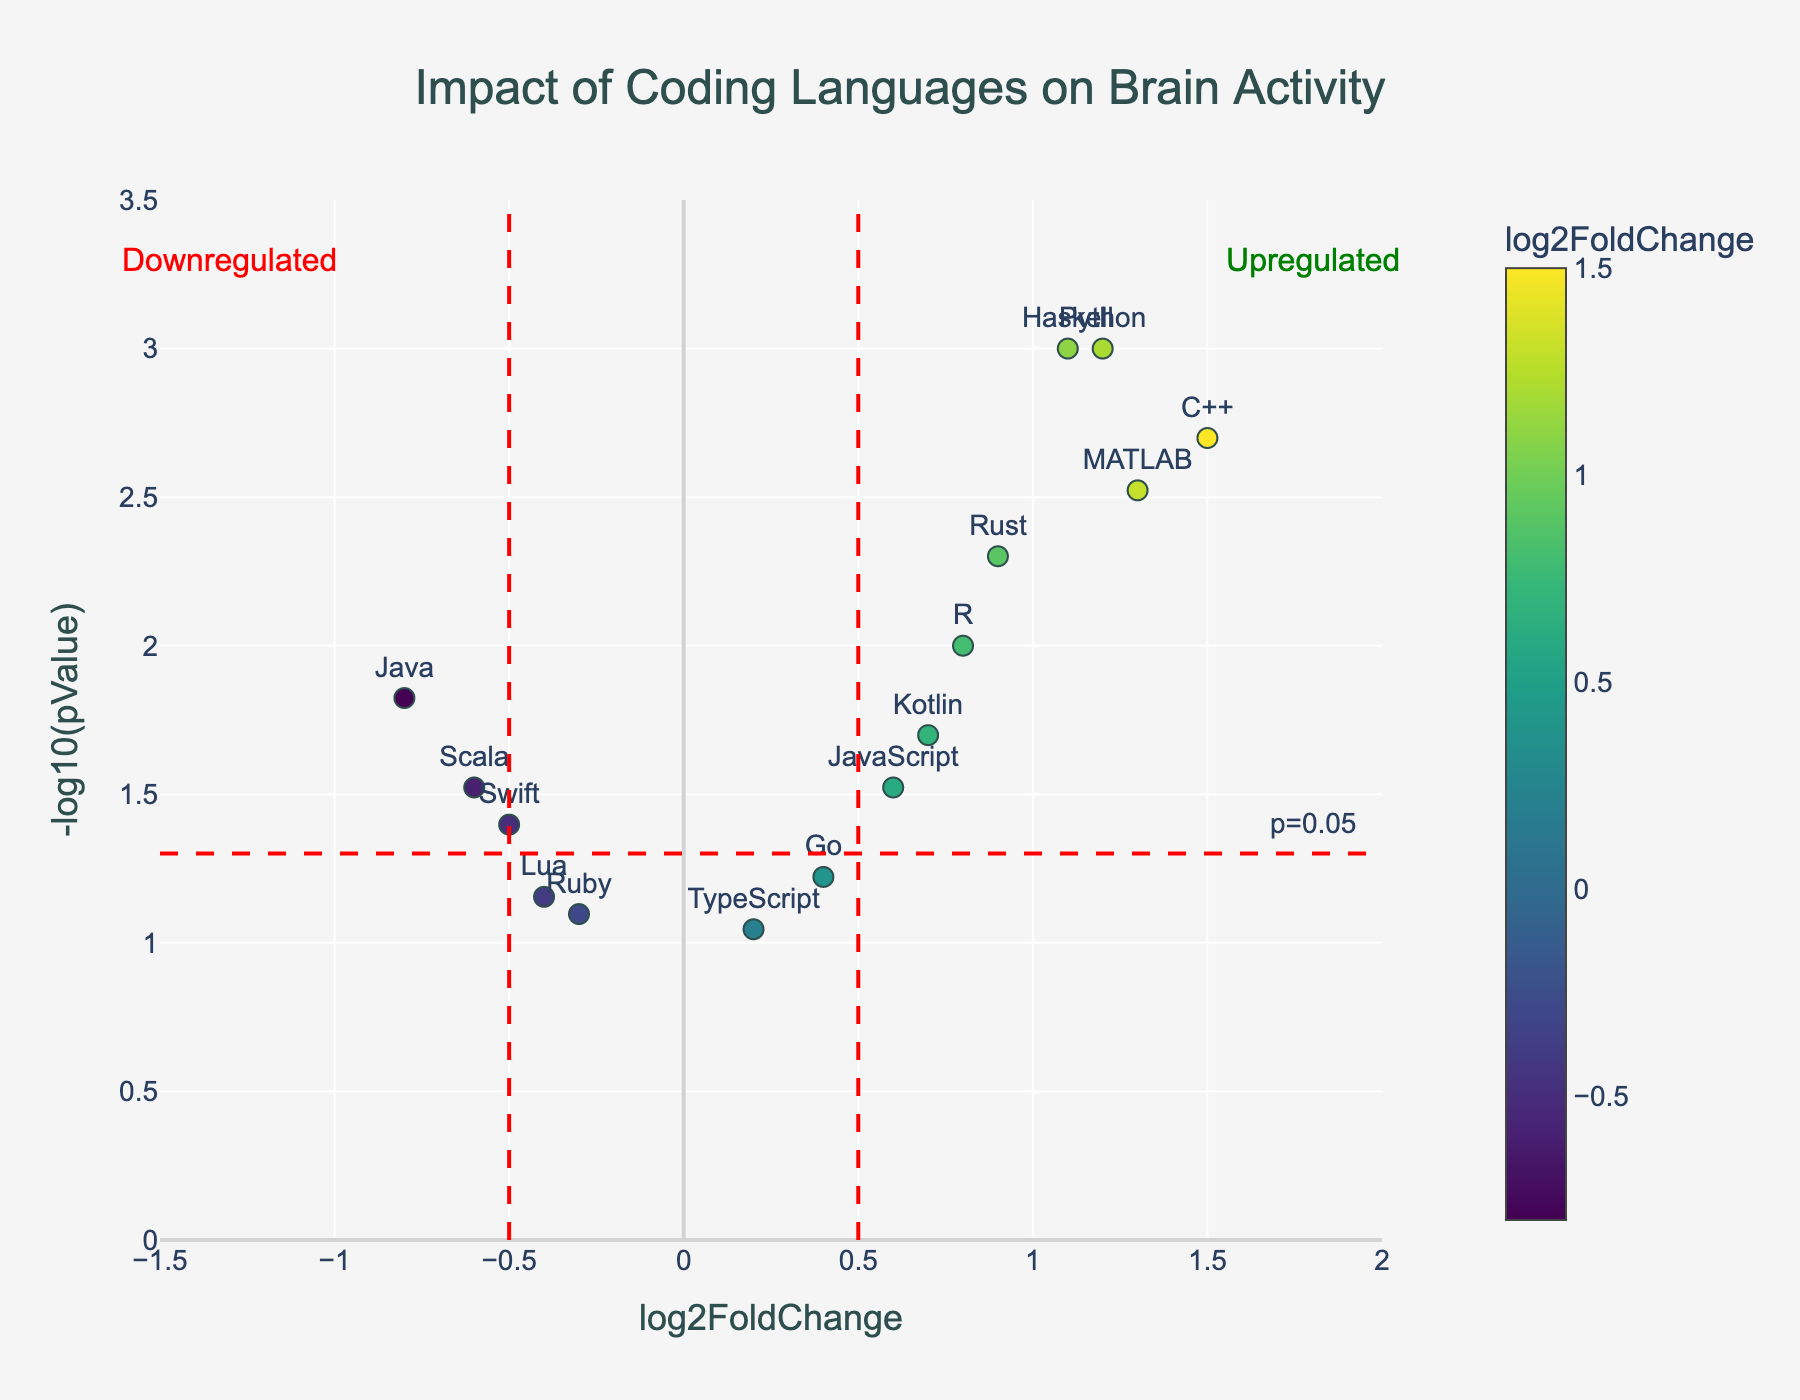Which coding language has the highest log2FoldChange? Look for the data point on the horizontal axis with the maximum log2FoldChange value. Python has a log2FoldChange of 1.2, JavaScript has 0.6, C++ has 1.5, and so on.
Answer: C++ Which coding language has the lowest p-value? Check the vertical axis for the data point with the largest -log10(pValue) value. Python has a -log10(pValue) of 3, C++ has 2.7, Rust has 2.3, and so on.
Answer: Python How many coding languages have a p-value below 0.05? Identify the data points above the horizontal line representing p=0.05 (-log10(0.05) ≈ 1.3). Count the points above this line.
Answer: 9 Which coding languages are considered upregulated based on the plot? Look for data points to the right of the vertical line at log2FoldChange=0.5. Upregulated languages have log2FoldChange greater than 0.5.
Answer: Python, JavaScript, C++, Kotlin, Haskell, Rust, MATLAB, R What is the log2FoldChange for the language Ruby? Identify the data point labeled Ruby and check its position on the horizontal axis.
Answer: -0.3 Compare the p-values for Java and Lua; which one is smaller? Find the -log10(pValue) for Java and Lua. Java has -log10(pValue) around 1.8, and Lua has around 1.2. The smaller p-value corresponds to the larger -log10(pValue).
Answer: Java Among Python, C++, and Rust, which language has the largest impact on brain activity? Compare the log2FoldChange for Python (1.2), C++ (1.5), and Rust (0.9) on the horizontal axis.
Answer: C++ How many coding languages fall into the downregulated category? Count the data points to the left of the vertical line at log2FoldChange=-0.5.
Answer: 3 What are the coordinates (log2FoldChange and -log10(pValue)) for the language R? Identify the data point labeled R and note its horizontal and vertical positions.
Answer: (0.8, 2) Compare the log2FoldChange values for Scala and Swift; which one is higher? Scala has a log2FoldChange of -0.6, and Swift has -0.5 on the horizontal axis. The higher value is closer to zero.
Answer: Swift 